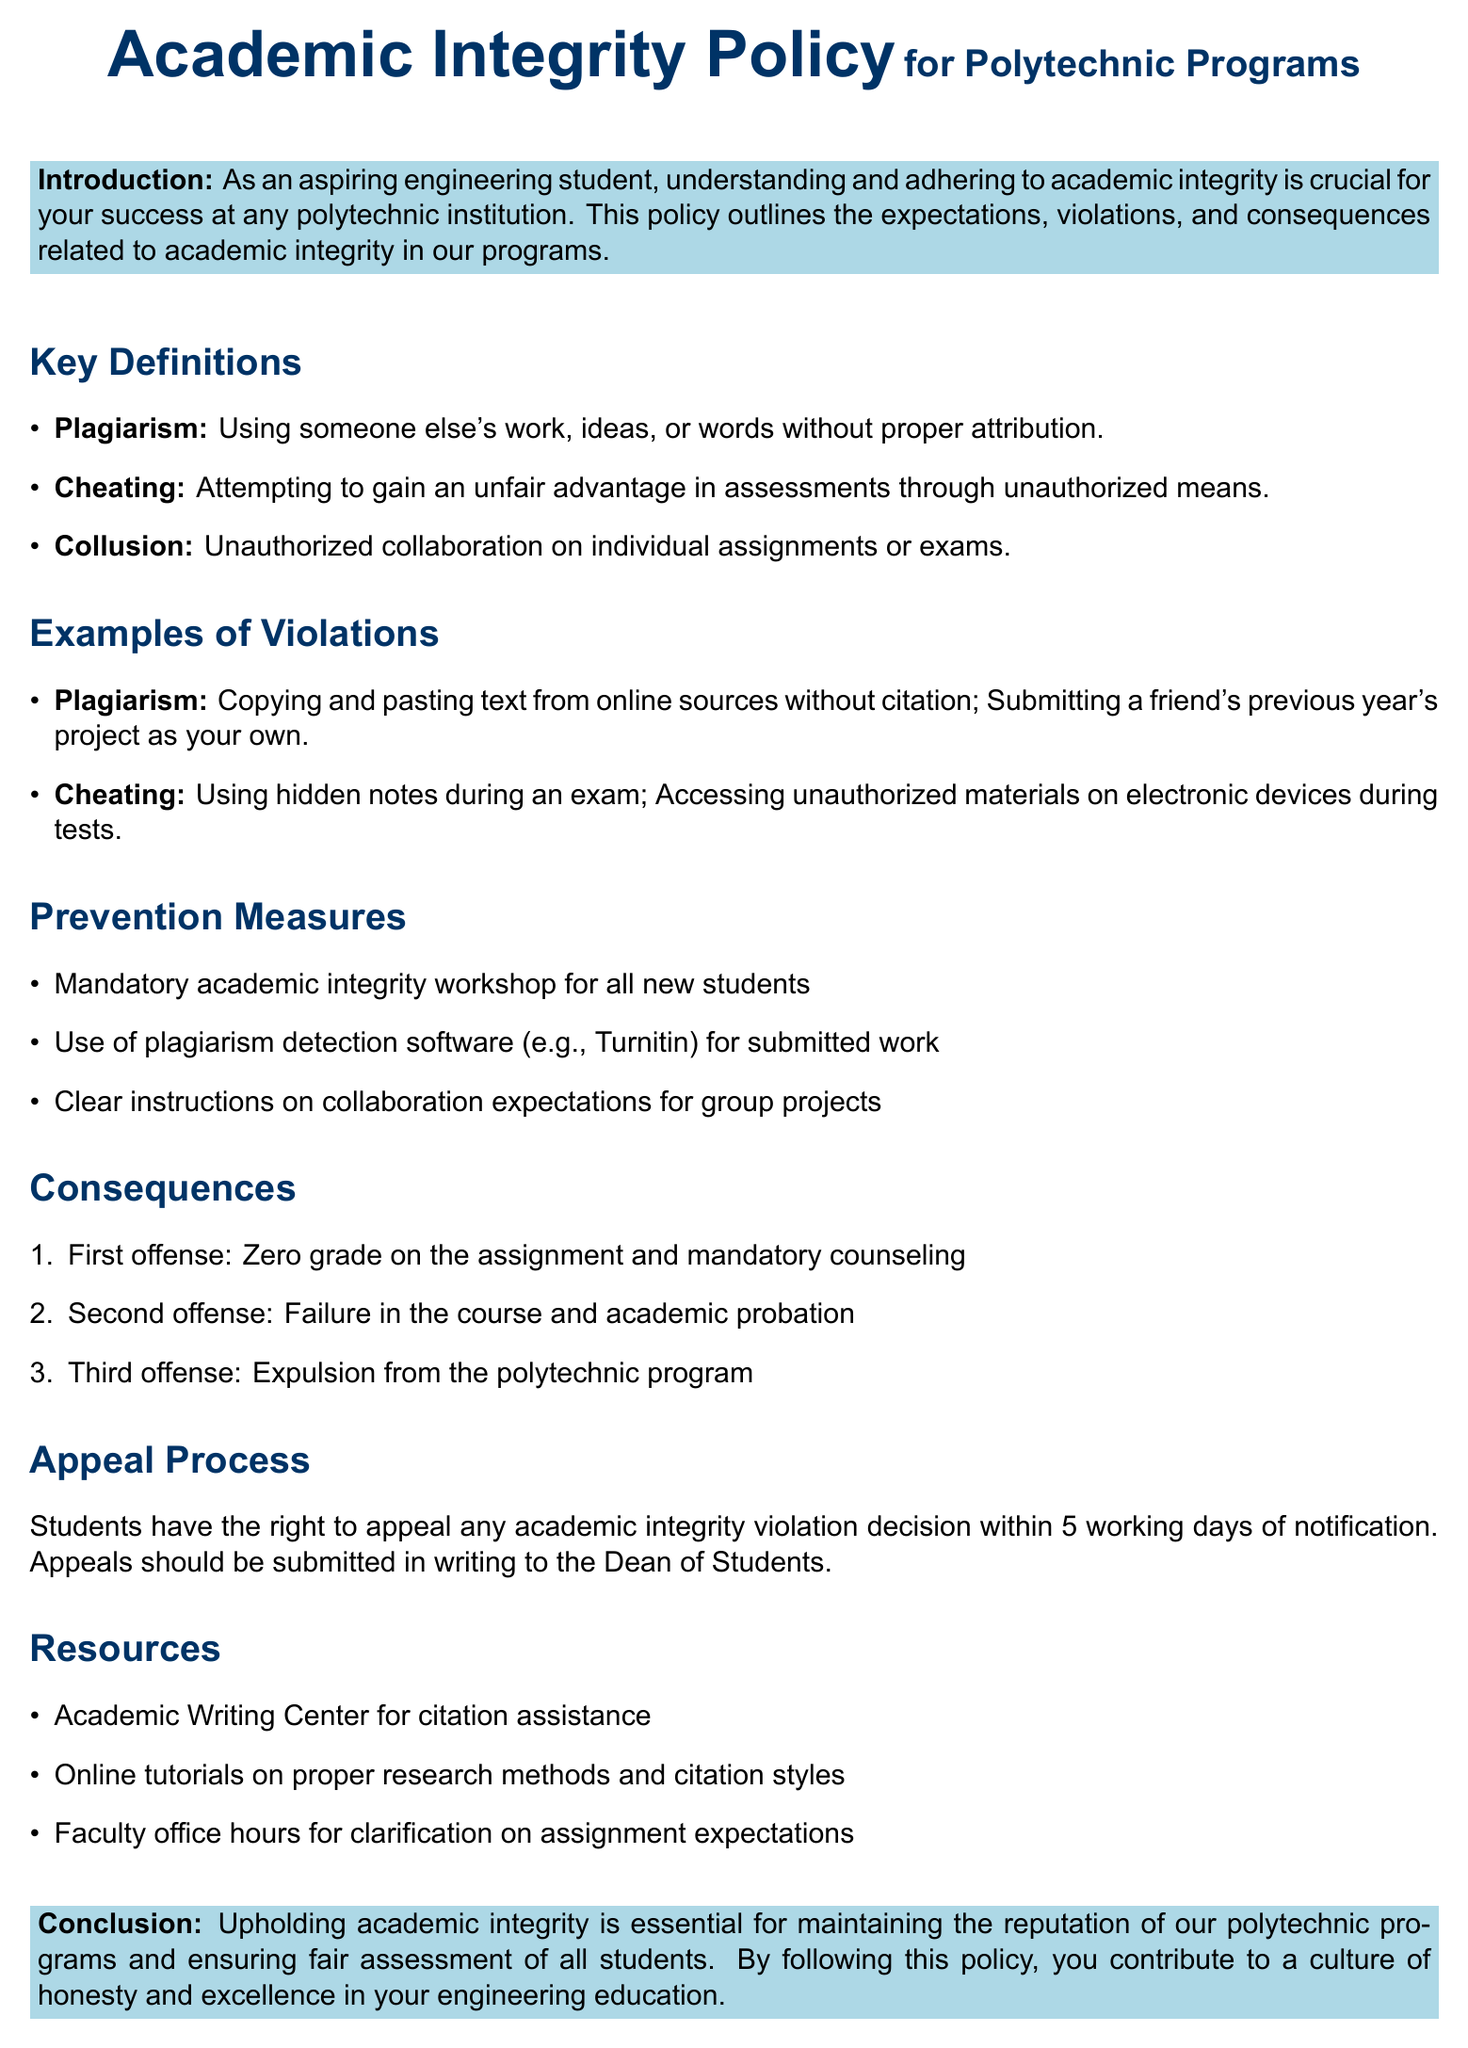What is the title of the policy document? The title of the policy document is about academic integrity for polytechnic programs.
Answer: Academic Integrity Policy for Polytechnic Programs What is defined as using someone else's work without proper attribution? This term is defined in the document and relates to the act of using another's work without citation.
Answer: Plagiarism What is the consequence for a second offense of academic integrity violations? The document states that a second offense leads to a specific academic consequence for the student.
Answer: Failure in the course and academic probation What is a measure included to prevent academic integrity violations? The document lists a specific workshop that all new students are required to attend as a preventive measure.
Answer: Mandatory academic integrity workshop How long do students have to appeal a violation decision? The document specifies a timeframe for students to submit an appeal after notification of a violation decision.
Answer: 5 working days What is an example of cheating provided in the document? One of the examples given relates to a specific action students might take during exams to gain an advantage.
Answer: Using hidden notes during an exam What should appeals be submitted to? The document outlines where students need to send their appeals concerning academic integrity violations.
Answer: Dean of Students What is mandatory for all new students regarding academic integrity? The document addresses a specific requirement imposed on new students to educate them about academic integrity.
Answer: Academic integrity workshop 